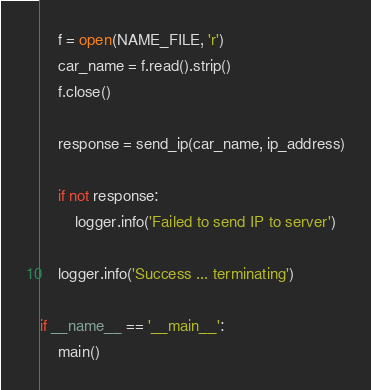<code> <loc_0><loc_0><loc_500><loc_500><_Python_>
    f = open(NAME_FILE, 'r')
    car_name = f.read().strip()
    f.close()

    response = send_ip(car_name, ip_address)

    if not response:
        logger.info('Failed to send IP to server')

    logger.info('Success ... terminating')

if __name__ == '__main__':
    main()</code> 